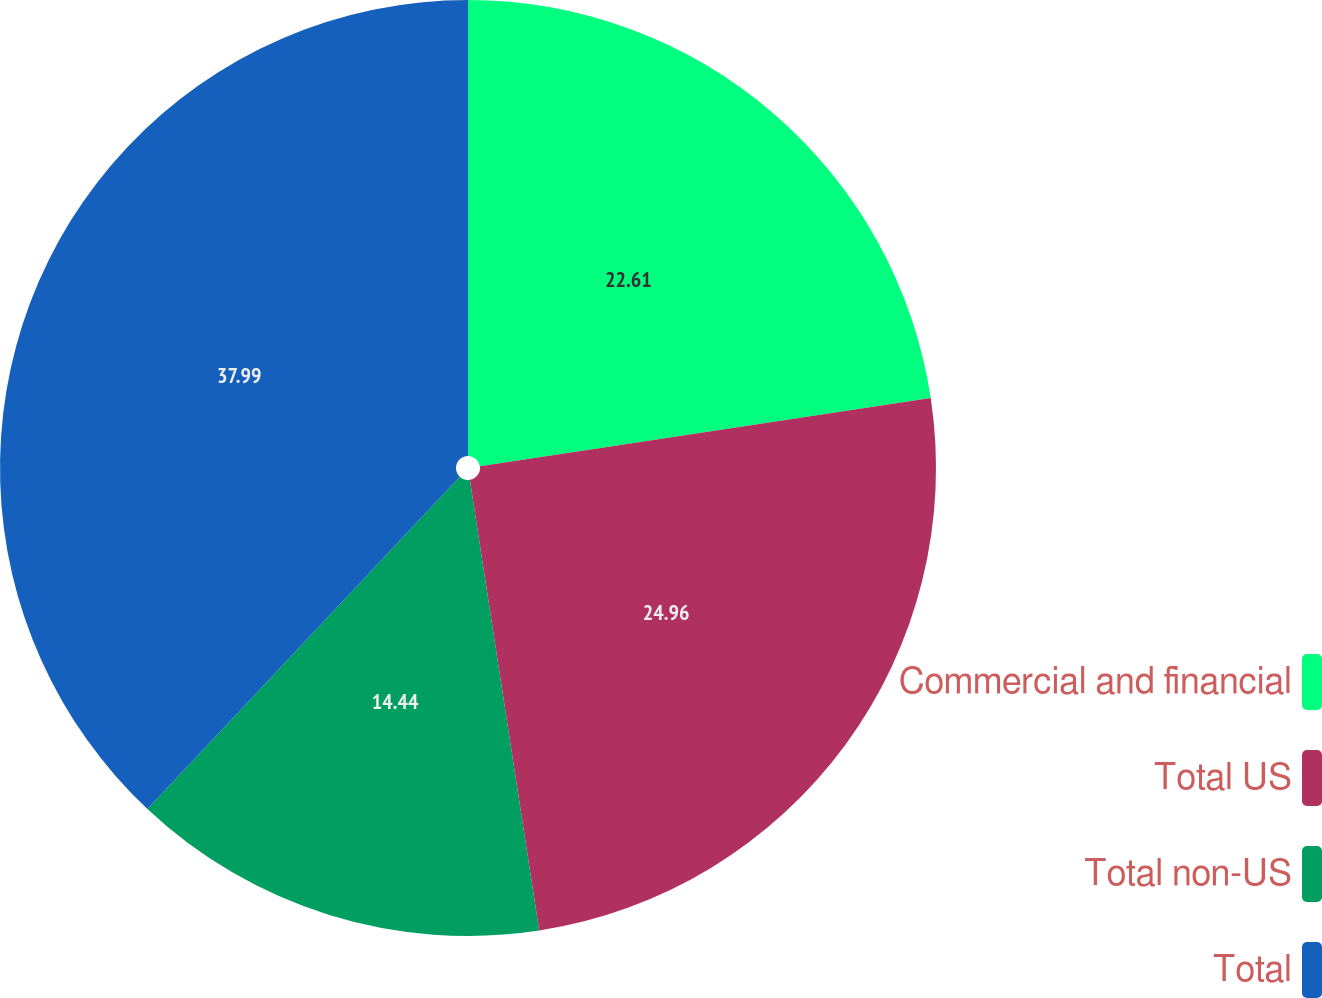Convert chart to OTSL. <chart><loc_0><loc_0><loc_500><loc_500><pie_chart><fcel>Commercial and financial<fcel>Total US<fcel>Total non-US<fcel>Total<nl><fcel>22.61%<fcel>24.96%<fcel>14.44%<fcel>37.99%<nl></chart> 